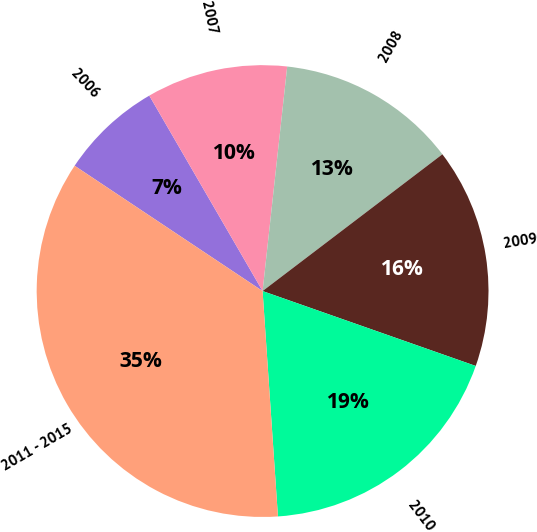Convert chart to OTSL. <chart><loc_0><loc_0><loc_500><loc_500><pie_chart><fcel>2006<fcel>2007<fcel>2008<fcel>2009<fcel>2010<fcel>2011 - 2015<nl><fcel>7.28%<fcel>10.1%<fcel>12.91%<fcel>15.73%<fcel>18.54%<fcel>35.44%<nl></chart> 